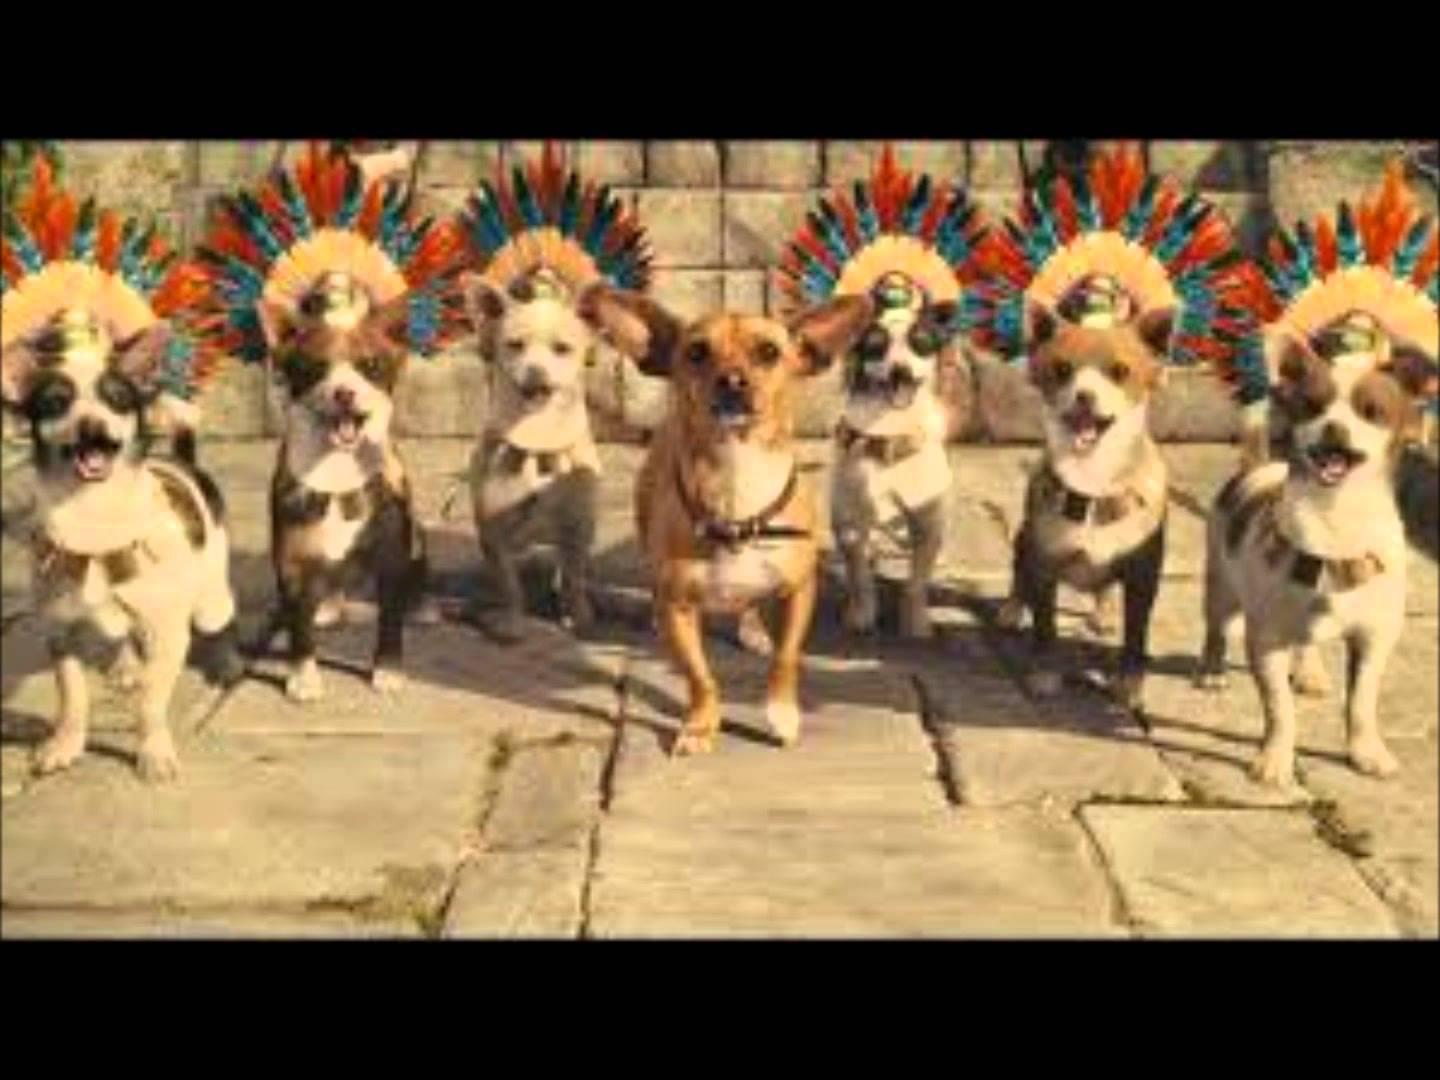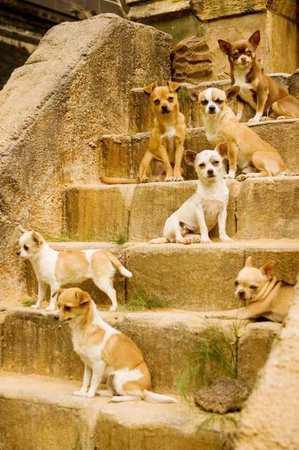The first image is the image on the left, the second image is the image on the right. Evaluate the accuracy of this statement regarding the images: "The images contain at least one row of chihuauas wearing something ornate around their necks and include at least one dog wearing a type of hat.". Is it true? Answer yes or no. Yes. The first image is the image on the left, the second image is the image on the right. Given the left and right images, does the statement "One dog in the image on the right is wearing a collar." hold true? Answer yes or no. No. 